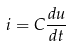Convert formula to latex. <formula><loc_0><loc_0><loc_500><loc_500>i = C \frac { d u } { d t }</formula> 